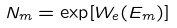<formula> <loc_0><loc_0><loc_500><loc_500>N _ { m } = \exp [ W _ { e } ( E _ { m } ) ]</formula> 